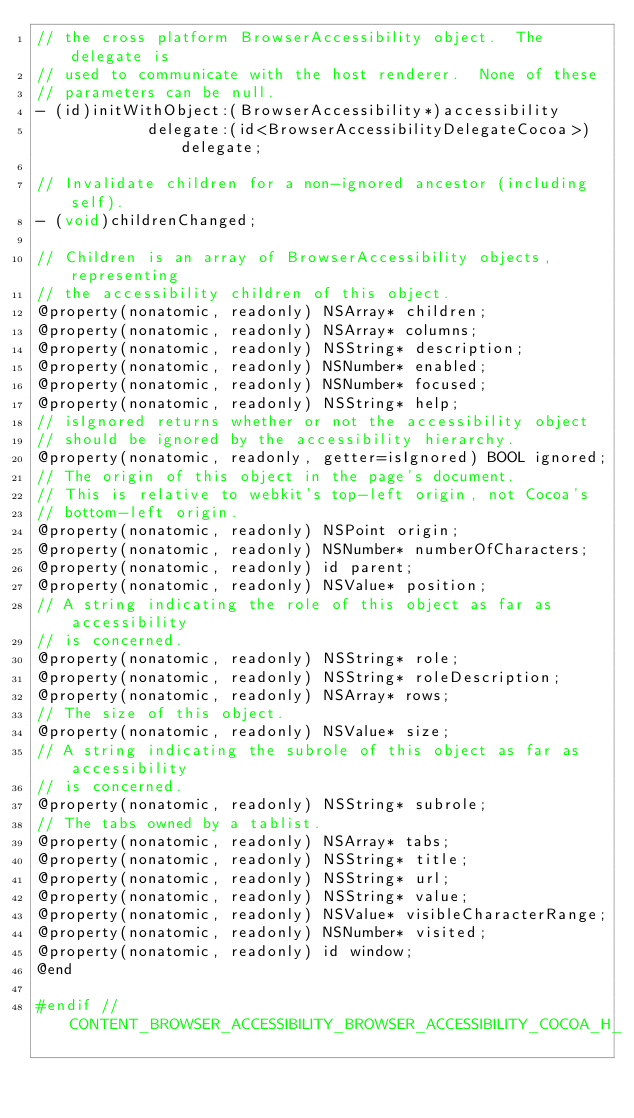<code> <loc_0><loc_0><loc_500><loc_500><_C_>// the cross platform BrowserAccessibility object.  The delegate is
// used to communicate with the host renderer.  None of these
// parameters can be null.
- (id)initWithObject:(BrowserAccessibility*)accessibility
            delegate:(id<BrowserAccessibilityDelegateCocoa>)delegate;

// Invalidate children for a non-ignored ancestor (including self).
- (void)childrenChanged;

// Children is an array of BrowserAccessibility objects, representing
// the accessibility children of this object.
@property(nonatomic, readonly) NSArray* children;
@property(nonatomic, readonly) NSArray* columns;
@property(nonatomic, readonly) NSString* description;
@property(nonatomic, readonly) NSNumber* enabled;
@property(nonatomic, readonly) NSNumber* focused;
@property(nonatomic, readonly) NSString* help;
// isIgnored returns whether or not the accessibility object
// should be ignored by the accessibility hierarchy.
@property(nonatomic, readonly, getter=isIgnored) BOOL ignored;
// The origin of this object in the page's document.
// This is relative to webkit's top-left origin, not Cocoa's
// bottom-left origin.
@property(nonatomic, readonly) NSPoint origin;
@property(nonatomic, readonly) NSNumber* numberOfCharacters;
@property(nonatomic, readonly) id parent;
@property(nonatomic, readonly) NSValue* position;
// A string indicating the role of this object as far as accessibility
// is concerned.
@property(nonatomic, readonly) NSString* role;
@property(nonatomic, readonly) NSString* roleDescription;
@property(nonatomic, readonly) NSArray* rows;
// The size of this object.
@property(nonatomic, readonly) NSValue* size;
// A string indicating the subrole of this object as far as accessibility
// is concerned.
@property(nonatomic, readonly) NSString* subrole;
// The tabs owned by a tablist.
@property(nonatomic, readonly) NSArray* tabs;
@property(nonatomic, readonly) NSString* title;
@property(nonatomic, readonly) NSString* url;
@property(nonatomic, readonly) NSString* value;
@property(nonatomic, readonly) NSValue* visibleCharacterRange;
@property(nonatomic, readonly) NSNumber* visited;
@property(nonatomic, readonly) id window;
@end

#endif // CONTENT_BROWSER_ACCESSIBILITY_BROWSER_ACCESSIBILITY_COCOA_H_
</code> 